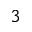Convert formula to latex. <formula><loc_0><loc_0><loc_500><loc_500>^ { 3 }</formula> 